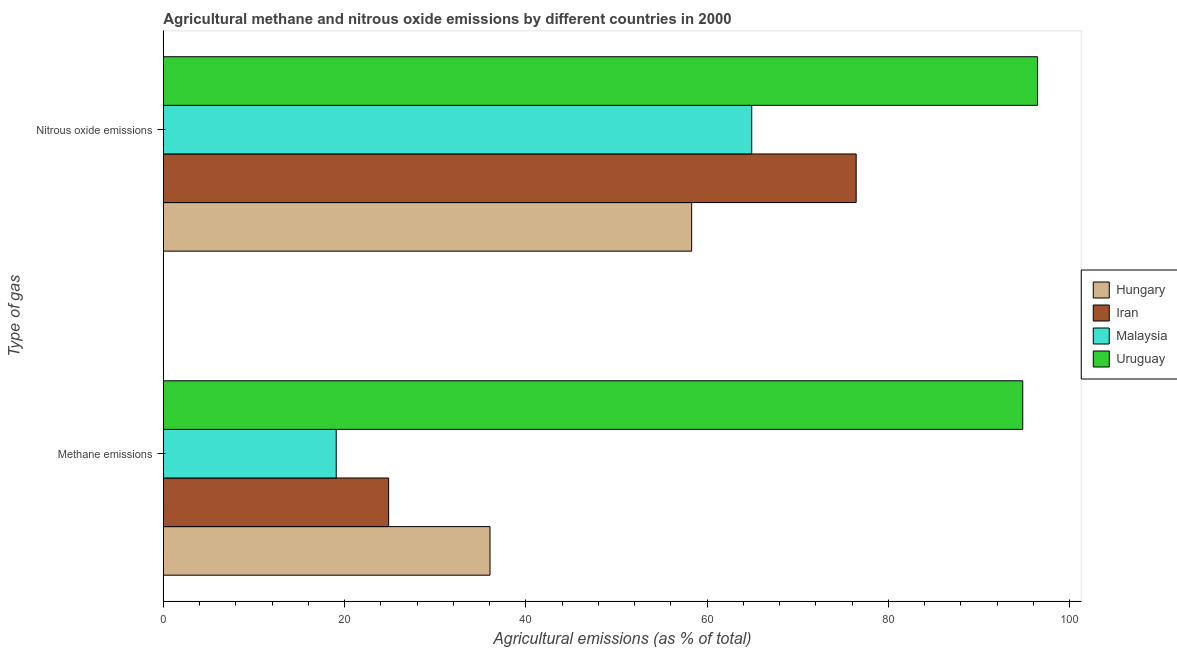Are the number of bars per tick equal to the number of legend labels?
Your answer should be very brief. Yes. What is the label of the 1st group of bars from the top?
Provide a succinct answer. Nitrous oxide emissions. What is the amount of methane emissions in Uruguay?
Your response must be concise. 94.82. Across all countries, what is the maximum amount of methane emissions?
Your answer should be compact. 94.82. Across all countries, what is the minimum amount of nitrous oxide emissions?
Provide a short and direct response. 58.29. In which country was the amount of methane emissions maximum?
Ensure brevity in your answer.  Uruguay. In which country was the amount of nitrous oxide emissions minimum?
Ensure brevity in your answer.  Hungary. What is the total amount of nitrous oxide emissions in the graph?
Provide a short and direct response. 296.1. What is the difference between the amount of nitrous oxide emissions in Hungary and that in Iran?
Your answer should be compact. -18.15. What is the difference between the amount of methane emissions in Uruguay and the amount of nitrous oxide emissions in Iran?
Make the answer very short. 18.38. What is the average amount of nitrous oxide emissions per country?
Provide a succinct answer. 74.03. What is the difference between the amount of methane emissions and amount of nitrous oxide emissions in Iran?
Make the answer very short. -51.58. What is the ratio of the amount of nitrous oxide emissions in Uruguay to that in Malaysia?
Your answer should be very brief. 1.49. Is the amount of methane emissions in Malaysia less than that in Iran?
Provide a succinct answer. Yes. In how many countries, is the amount of nitrous oxide emissions greater than the average amount of nitrous oxide emissions taken over all countries?
Your answer should be very brief. 2. What does the 3rd bar from the top in Methane emissions represents?
Your answer should be compact. Iran. What does the 4th bar from the bottom in Methane emissions represents?
Offer a terse response. Uruguay. How many bars are there?
Offer a very short reply. 8. What is the difference between two consecutive major ticks on the X-axis?
Keep it short and to the point. 20. Are the values on the major ticks of X-axis written in scientific E-notation?
Offer a terse response. No. What is the title of the graph?
Provide a succinct answer. Agricultural methane and nitrous oxide emissions by different countries in 2000. Does "Mexico" appear as one of the legend labels in the graph?
Provide a succinct answer. No. What is the label or title of the X-axis?
Keep it short and to the point. Agricultural emissions (as % of total). What is the label or title of the Y-axis?
Make the answer very short. Type of gas. What is the Agricultural emissions (as % of total) of Hungary in Methane emissions?
Your answer should be very brief. 36.04. What is the Agricultural emissions (as % of total) in Iran in Methane emissions?
Your answer should be compact. 24.86. What is the Agricultural emissions (as % of total) of Malaysia in Methane emissions?
Your response must be concise. 19.08. What is the Agricultural emissions (as % of total) of Uruguay in Methane emissions?
Your answer should be compact. 94.82. What is the Agricultural emissions (as % of total) of Hungary in Nitrous oxide emissions?
Keep it short and to the point. 58.29. What is the Agricultural emissions (as % of total) of Iran in Nitrous oxide emissions?
Offer a very short reply. 76.44. What is the Agricultural emissions (as % of total) in Malaysia in Nitrous oxide emissions?
Keep it short and to the point. 64.92. What is the Agricultural emissions (as % of total) of Uruguay in Nitrous oxide emissions?
Make the answer very short. 96.45. Across all Type of gas, what is the maximum Agricultural emissions (as % of total) of Hungary?
Keep it short and to the point. 58.29. Across all Type of gas, what is the maximum Agricultural emissions (as % of total) of Iran?
Give a very brief answer. 76.44. Across all Type of gas, what is the maximum Agricultural emissions (as % of total) of Malaysia?
Offer a terse response. 64.92. Across all Type of gas, what is the maximum Agricultural emissions (as % of total) in Uruguay?
Make the answer very short. 96.45. Across all Type of gas, what is the minimum Agricultural emissions (as % of total) of Hungary?
Offer a terse response. 36.04. Across all Type of gas, what is the minimum Agricultural emissions (as % of total) in Iran?
Offer a terse response. 24.86. Across all Type of gas, what is the minimum Agricultural emissions (as % of total) in Malaysia?
Offer a very short reply. 19.08. Across all Type of gas, what is the minimum Agricultural emissions (as % of total) in Uruguay?
Offer a terse response. 94.82. What is the total Agricultural emissions (as % of total) in Hungary in the graph?
Your response must be concise. 94.33. What is the total Agricultural emissions (as % of total) in Iran in the graph?
Offer a very short reply. 101.3. What is the total Agricultural emissions (as % of total) of Malaysia in the graph?
Ensure brevity in your answer.  84. What is the total Agricultural emissions (as % of total) of Uruguay in the graph?
Offer a very short reply. 191.27. What is the difference between the Agricultural emissions (as % of total) in Hungary in Methane emissions and that in Nitrous oxide emissions?
Keep it short and to the point. -22.25. What is the difference between the Agricultural emissions (as % of total) of Iran in Methane emissions and that in Nitrous oxide emissions?
Ensure brevity in your answer.  -51.58. What is the difference between the Agricultural emissions (as % of total) in Malaysia in Methane emissions and that in Nitrous oxide emissions?
Your answer should be compact. -45.84. What is the difference between the Agricultural emissions (as % of total) of Uruguay in Methane emissions and that in Nitrous oxide emissions?
Offer a very short reply. -1.63. What is the difference between the Agricultural emissions (as % of total) in Hungary in Methane emissions and the Agricultural emissions (as % of total) in Iran in Nitrous oxide emissions?
Your response must be concise. -40.4. What is the difference between the Agricultural emissions (as % of total) of Hungary in Methane emissions and the Agricultural emissions (as % of total) of Malaysia in Nitrous oxide emissions?
Keep it short and to the point. -28.87. What is the difference between the Agricultural emissions (as % of total) of Hungary in Methane emissions and the Agricultural emissions (as % of total) of Uruguay in Nitrous oxide emissions?
Your response must be concise. -60.41. What is the difference between the Agricultural emissions (as % of total) of Iran in Methane emissions and the Agricultural emissions (as % of total) of Malaysia in Nitrous oxide emissions?
Make the answer very short. -40.06. What is the difference between the Agricultural emissions (as % of total) in Iran in Methane emissions and the Agricultural emissions (as % of total) in Uruguay in Nitrous oxide emissions?
Offer a very short reply. -71.59. What is the difference between the Agricultural emissions (as % of total) of Malaysia in Methane emissions and the Agricultural emissions (as % of total) of Uruguay in Nitrous oxide emissions?
Your answer should be very brief. -77.37. What is the average Agricultural emissions (as % of total) in Hungary per Type of gas?
Offer a very short reply. 47.17. What is the average Agricultural emissions (as % of total) in Iran per Type of gas?
Keep it short and to the point. 50.65. What is the average Agricultural emissions (as % of total) of Malaysia per Type of gas?
Keep it short and to the point. 42. What is the average Agricultural emissions (as % of total) of Uruguay per Type of gas?
Your answer should be very brief. 95.63. What is the difference between the Agricultural emissions (as % of total) in Hungary and Agricultural emissions (as % of total) in Iran in Methane emissions?
Provide a succinct answer. 11.18. What is the difference between the Agricultural emissions (as % of total) in Hungary and Agricultural emissions (as % of total) in Malaysia in Methane emissions?
Your response must be concise. 16.96. What is the difference between the Agricultural emissions (as % of total) of Hungary and Agricultural emissions (as % of total) of Uruguay in Methane emissions?
Ensure brevity in your answer.  -58.77. What is the difference between the Agricultural emissions (as % of total) in Iran and Agricultural emissions (as % of total) in Malaysia in Methane emissions?
Offer a terse response. 5.78. What is the difference between the Agricultural emissions (as % of total) in Iran and Agricultural emissions (as % of total) in Uruguay in Methane emissions?
Offer a terse response. -69.96. What is the difference between the Agricultural emissions (as % of total) of Malaysia and Agricultural emissions (as % of total) of Uruguay in Methane emissions?
Offer a terse response. -75.74. What is the difference between the Agricultural emissions (as % of total) in Hungary and Agricultural emissions (as % of total) in Iran in Nitrous oxide emissions?
Your answer should be very brief. -18.15. What is the difference between the Agricultural emissions (as % of total) in Hungary and Agricultural emissions (as % of total) in Malaysia in Nitrous oxide emissions?
Offer a terse response. -6.63. What is the difference between the Agricultural emissions (as % of total) in Hungary and Agricultural emissions (as % of total) in Uruguay in Nitrous oxide emissions?
Provide a short and direct response. -38.16. What is the difference between the Agricultural emissions (as % of total) in Iran and Agricultural emissions (as % of total) in Malaysia in Nitrous oxide emissions?
Offer a terse response. 11.52. What is the difference between the Agricultural emissions (as % of total) of Iran and Agricultural emissions (as % of total) of Uruguay in Nitrous oxide emissions?
Keep it short and to the point. -20.01. What is the difference between the Agricultural emissions (as % of total) in Malaysia and Agricultural emissions (as % of total) in Uruguay in Nitrous oxide emissions?
Your answer should be compact. -31.53. What is the ratio of the Agricultural emissions (as % of total) of Hungary in Methane emissions to that in Nitrous oxide emissions?
Your answer should be compact. 0.62. What is the ratio of the Agricultural emissions (as % of total) in Iran in Methane emissions to that in Nitrous oxide emissions?
Your response must be concise. 0.33. What is the ratio of the Agricultural emissions (as % of total) in Malaysia in Methane emissions to that in Nitrous oxide emissions?
Keep it short and to the point. 0.29. What is the ratio of the Agricultural emissions (as % of total) in Uruguay in Methane emissions to that in Nitrous oxide emissions?
Provide a succinct answer. 0.98. What is the difference between the highest and the second highest Agricultural emissions (as % of total) of Hungary?
Your answer should be compact. 22.25. What is the difference between the highest and the second highest Agricultural emissions (as % of total) of Iran?
Ensure brevity in your answer.  51.58. What is the difference between the highest and the second highest Agricultural emissions (as % of total) in Malaysia?
Your response must be concise. 45.84. What is the difference between the highest and the second highest Agricultural emissions (as % of total) in Uruguay?
Your answer should be very brief. 1.63. What is the difference between the highest and the lowest Agricultural emissions (as % of total) of Hungary?
Provide a succinct answer. 22.25. What is the difference between the highest and the lowest Agricultural emissions (as % of total) of Iran?
Your answer should be very brief. 51.58. What is the difference between the highest and the lowest Agricultural emissions (as % of total) of Malaysia?
Your answer should be compact. 45.84. What is the difference between the highest and the lowest Agricultural emissions (as % of total) in Uruguay?
Your response must be concise. 1.63. 